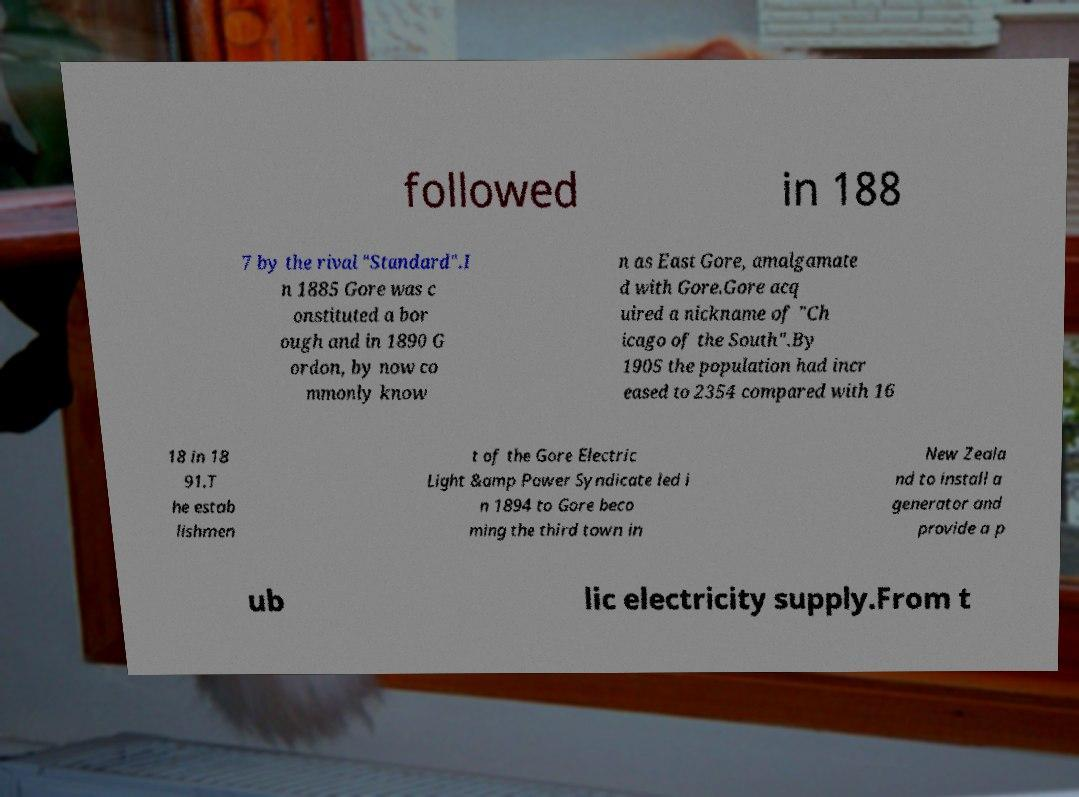Please read and relay the text visible in this image. What does it say? followed in 188 7 by the rival "Standard".I n 1885 Gore was c onstituted a bor ough and in 1890 G ordon, by now co mmonly know n as East Gore, amalgamate d with Gore.Gore acq uired a nickname of "Ch icago of the South".By 1905 the population had incr eased to 2354 compared with 16 18 in 18 91.T he estab lishmen t of the Gore Electric Light &amp Power Syndicate led i n 1894 to Gore beco ming the third town in New Zeala nd to install a generator and provide a p ub lic electricity supply.From t 